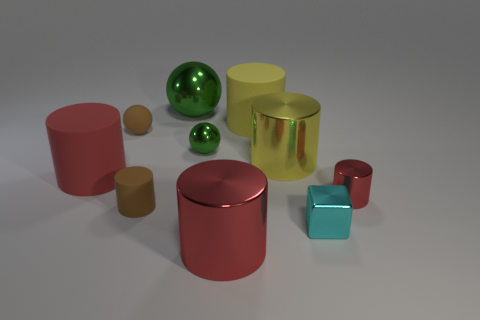Subtract all small brown matte cylinders. How many cylinders are left? 5 Subtract all green balls. How many red cylinders are left? 3 Subtract 1 spheres. How many spheres are left? 2 Subtract all cubes. How many objects are left? 9 Subtract all brown cylinders. How many cylinders are left? 5 Add 3 matte spheres. How many matte spheres are left? 4 Add 3 red matte cylinders. How many red matte cylinders exist? 4 Subtract 0 blue cylinders. How many objects are left? 10 Subtract all red spheres. Subtract all blue blocks. How many spheres are left? 3 Subtract all cyan spheres. Subtract all red metallic cylinders. How many objects are left? 8 